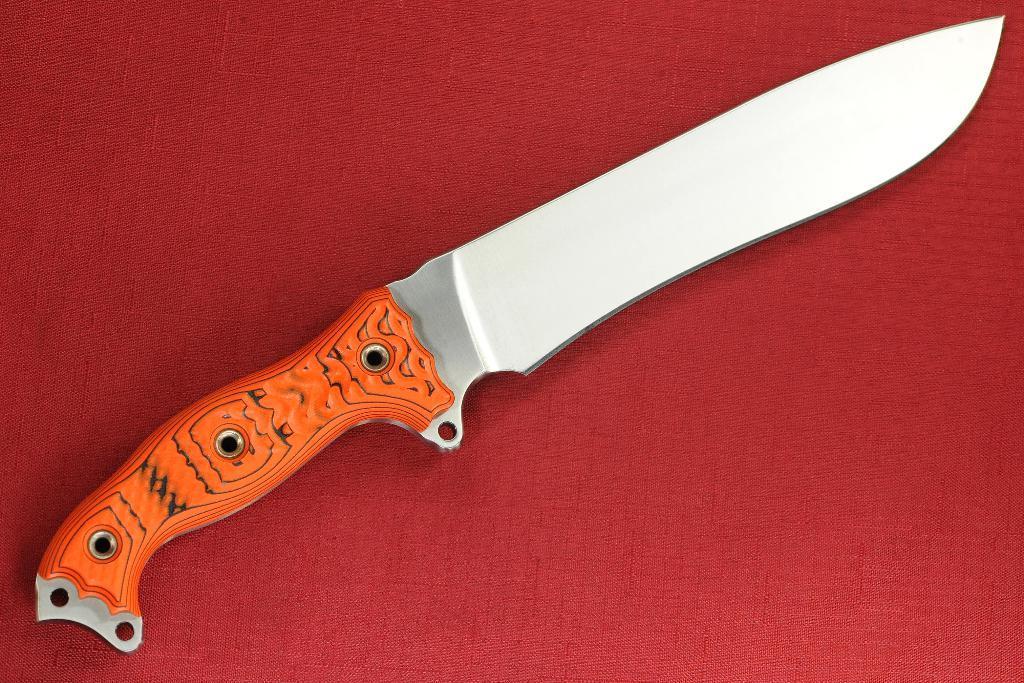Please provide a concise description of this image. In this image, we can see a knife. Orange color holder. That is placed on a red color mat. 